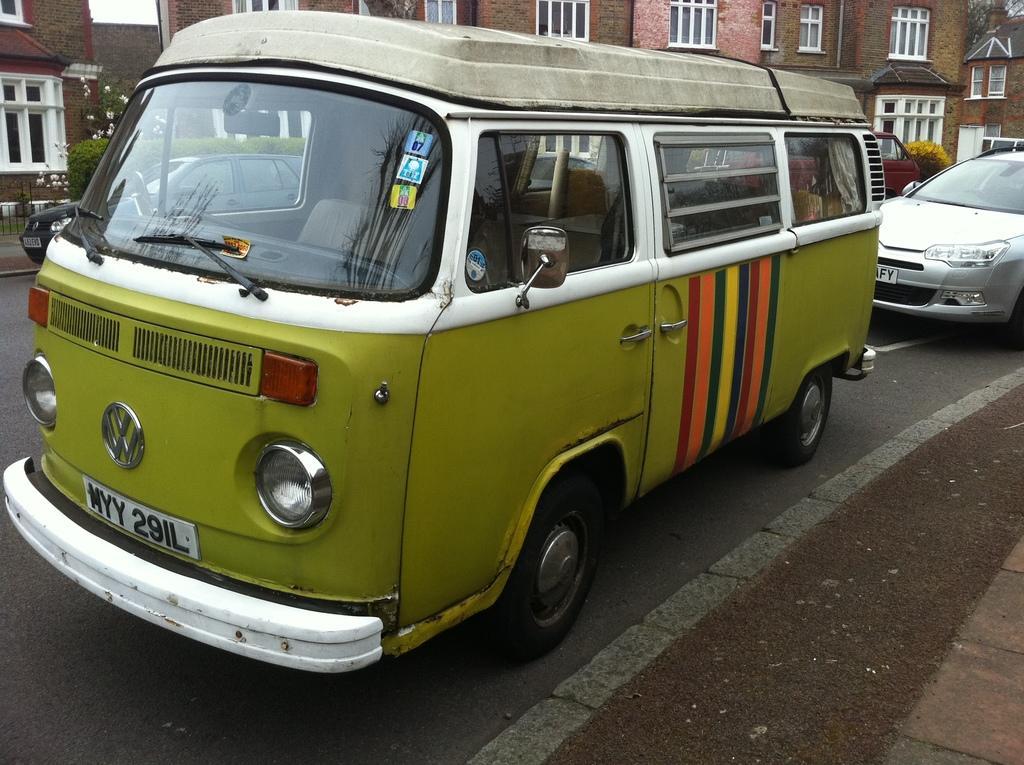Please provide a concise description of this image. In this picture we can see few vehicles on the road, in the background we can see few trees, buildings and fence, and also we can see flowers. 